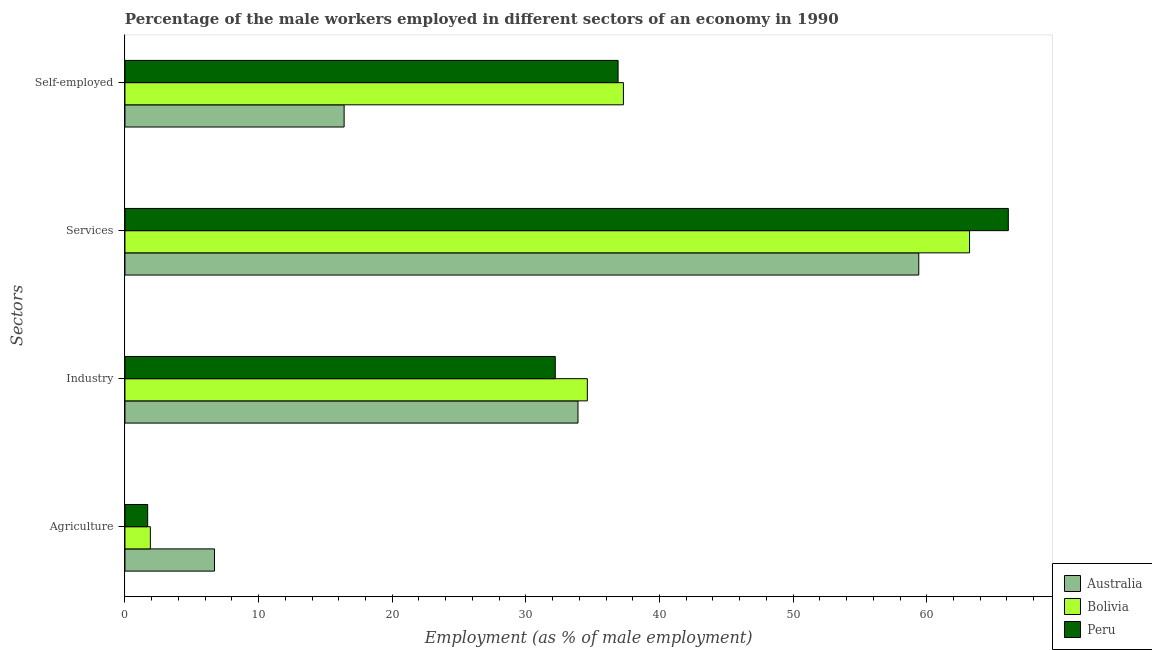How many different coloured bars are there?
Provide a succinct answer. 3. Are the number of bars on each tick of the Y-axis equal?
Your answer should be very brief. Yes. How many bars are there on the 1st tick from the bottom?
Your answer should be very brief. 3. What is the label of the 3rd group of bars from the top?
Keep it short and to the point. Industry. What is the percentage of male workers in agriculture in Bolivia?
Provide a short and direct response. 1.9. Across all countries, what is the maximum percentage of self employed male workers?
Your answer should be very brief. 37.3. Across all countries, what is the minimum percentage of self employed male workers?
Your answer should be very brief. 16.4. What is the total percentage of self employed male workers in the graph?
Your response must be concise. 90.6. What is the difference between the percentage of male workers in industry in Peru and that in Australia?
Your answer should be compact. -1.7. What is the difference between the percentage of male workers in services in Bolivia and the percentage of male workers in industry in Peru?
Offer a terse response. 31. What is the average percentage of male workers in industry per country?
Ensure brevity in your answer.  33.57. What is the difference between the percentage of self employed male workers and percentage of male workers in agriculture in Bolivia?
Offer a very short reply. 35.4. What is the ratio of the percentage of male workers in services in Peru to that in Australia?
Give a very brief answer. 1.11. Is the percentage of male workers in industry in Peru less than that in Bolivia?
Give a very brief answer. Yes. What is the difference between the highest and the second highest percentage of self employed male workers?
Your answer should be very brief. 0.4. What is the difference between the highest and the lowest percentage of male workers in industry?
Your answer should be compact. 2.4. In how many countries, is the percentage of male workers in services greater than the average percentage of male workers in services taken over all countries?
Provide a succinct answer. 2. Is it the case that in every country, the sum of the percentage of male workers in agriculture and percentage of self employed male workers is greater than the sum of percentage of male workers in services and percentage of male workers in industry?
Provide a succinct answer. No. Is it the case that in every country, the sum of the percentage of male workers in agriculture and percentage of male workers in industry is greater than the percentage of male workers in services?
Offer a very short reply. No. How many bars are there?
Provide a short and direct response. 12. Are all the bars in the graph horizontal?
Your answer should be very brief. Yes. How many countries are there in the graph?
Keep it short and to the point. 3. Are the values on the major ticks of X-axis written in scientific E-notation?
Ensure brevity in your answer.  No. Does the graph contain grids?
Provide a succinct answer. No. Where does the legend appear in the graph?
Ensure brevity in your answer.  Bottom right. How are the legend labels stacked?
Your answer should be very brief. Vertical. What is the title of the graph?
Make the answer very short. Percentage of the male workers employed in different sectors of an economy in 1990. Does "Syrian Arab Republic" appear as one of the legend labels in the graph?
Your answer should be very brief. No. What is the label or title of the X-axis?
Offer a very short reply. Employment (as % of male employment). What is the label or title of the Y-axis?
Give a very brief answer. Sectors. What is the Employment (as % of male employment) of Australia in Agriculture?
Provide a succinct answer. 6.7. What is the Employment (as % of male employment) of Bolivia in Agriculture?
Provide a short and direct response. 1.9. What is the Employment (as % of male employment) in Peru in Agriculture?
Give a very brief answer. 1.7. What is the Employment (as % of male employment) in Australia in Industry?
Make the answer very short. 33.9. What is the Employment (as % of male employment) in Bolivia in Industry?
Give a very brief answer. 34.6. What is the Employment (as % of male employment) of Peru in Industry?
Ensure brevity in your answer.  32.2. What is the Employment (as % of male employment) in Australia in Services?
Offer a terse response. 59.4. What is the Employment (as % of male employment) in Bolivia in Services?
Provide a succinct answer. 63.2. What is the Employment (as % of male employment) of Peru in Services?
Keep it short and to the point. 66.1. What is the Employment (as % of male employment) in Australia in Self-employed?
Your answer should be very brief. 16.4. What is the Employment (as % of male employment) of Bolivia in Self-employed?
Give a very brief answer. 37.3. What is the Employment (as % of male employment) in Peru in Self-employed?
Give a very brief answer. 36.9. Across all Sectors, what is the maximum Employment (as % of male employment) of Australia?
Offer a terse response. 59.4. Across all Sectors, what is the maximum Employment (as % of male employment) of Bolivia?
Offer a terse response. 63.2. Across all Sectors, what is the maximum Employment (as % of male employment) of Peru?
Provide a short and direct response. 66.1. Across all Sectors, what is the minimum Employment (as % of male employment) in Australia?
Provide a short and direct response. 6.7. Across all Sectors, what is the minimum Employment (as % of male employment) of Bolivia?
Your response must be concise. 1.9. Across all Sectors, what is the minimum Employment (as % of male employment) of Peru?
Give a very brief answer. 1.7. What is the total Employment (as % of male employment) of Australia in the graph?
Provide a succinct answer. 116.4. What is the total Employment (as % of male employment) of Bolivia in the graph?
Give a very brief answer. 137. What is the total Employment (as % of male employment) in Peru in the graph?
Ensure brevity in your answer.  136.9. What is the difference between the Employment (as % of male employment) in Australia in Agriculture and that in Industry?
Keep it short and to the point. -27.2. What is the difference between the Employment (as % of male employment) of Bolivia in Agriculture and that in Industry?
Your answer should be very brief. -32.7. What is the difference between the Employment (as % of male employment) of Peru in Agriculture and that in Industry?
Offer a very short reply. -30.5. What is the difference between the Employment (as % of male employment) of Australia in Agriculture and that in Services?
Offer a terse response. -52.7. What is the difference between the Employment (as % of male employment) in Bolivia in Agriculture and that in Services?
Provide a short and direct response. -61.3. What is the difference between the Employment (as % of male employment) in Peru in Agriculture and that in Services?
Provide a short and direct response. -64.4. What is the difference between the Employment (as % of male employment) in Australia in Agriculture and that in Self-employed?
Your answer should be very brief. -9.7. What is the difference between the Employment (as % of male employment) in Bolivia in Agriculture and that in Self-employed?
Offer a very short reply. -35.4. What is the difference between the Employment (as % of male employment) in Peru in Agriculture and that in Self-employed?
Your answer should be compact. -35.2. What is the difference between the Employment (as % of male employment) of Australia in Industry and that in Services?
Provide a short and direct response. -25.5. What is the difference between the Employment (as % of male employment) in Bolivia in Industry and that in Services?
Keep it short and to the point. -28.6. What is the difference between the Employment (as % of male employment) of Peru in Industry and that in Services?
Keep it short and to the point. -33.9. What is the difference between the Employment (as % of male employment) in Australia in Industry and that in Self-employed?
Ensure brevity in your answer.  17.5. What is the difference between the Employment (as % of male employment) in Bolivia in Industry and that in Self-employed?
Offer a terse response. -2.7. What is the difference between the Employment (as % of male employment) of Peru in Industry and that in Self-employed?
Offer a terse response. -4.7. What is the difference between the Employment (as % of male employment) of Bolivia in Services and that in Self-employed?
Offer a terse response. 25.9. What is the difference between the Employment (as % of male employment) of Peru in Services and that in Self-employed?
Your answer should be compact. 29.2. What is the difference between the Employment (as % of male employment) in Australia in Agriculture and the Employment (as % of male employment) in Bolivia in Industry?
Provide a short and direct response. -27.9. What is the difference between the Employment (as % of male employment) in Australia in Agriculture and the Employment (as % of male employment) in Peru in Industry?
Provide a short and direct response. -25.5. What is the difference between the Employment (as % of male employment) of Bolivia in Agriculture and the Employment (as % of male employment) of Peru in Industry?
Give a very brief answer. -30.3. What is the difference between the Employment (as % of male employment) in Australia in Agriculture and the Employment (as % of male employment) in Bolivia in Services?
Your answer should be compact. -56.5. What is the difference between the Employment (as % of male employment) of Australia in Agriculture and the Employment (as % of male employment) of Peru in Services?
Provide a short and direct response. -59.4. What is the difference between the Employment (as % of male employment) of Bolivia in Agriculture and the Employment (as % of male employment) of Peru in Services?
Provide a succinct answer. -64.2. What is the difference between the Employment (as % of male employment) of Australia in Agriculture and the Employment (as % of male employment) of Bolivia in Self-employed?
Your answer should be compact. -30.6. What is the difference between the Employment (as % of male employment) in Australia in Agriculture and the Employment (as % of male employment) in Peru in Self-employed?
Provide a succinct answer. -30.2. What is the difference between the Employment (as % of male employment) in Bolivia in Agriculture and the Employment (as % of male employment) in Peru in Self-employed?
Keep it short and to the point. -35. What is the difference between the Employment (as % of male employment) in Australia in Industry and the Employment (as % of male employment) in Bolivia in Services?
Your answer should be compact. -29.3. What is the difference between the Employment (as % of male employment) of Australia in Industry and the Employment (as % of male employment) of Peru in Services?
Provide a short and direct response. -32.2. What is the difference between the Employment (as % of male employment) in Bolivia in Industry and the Employment (as % of male employment) in Peru in Services?
Ensure brevity in your answer.  -31.5. What is the difference between the Employment (as % of male employment) of Australia in Industry and the Employment (as % of male employment) of Bolivia in Self-employed?
Your answer should be very brief. -3.4. What is the difference between the Employment (as % of male employment) in Australia in Industry and the Employment (as % of male employment) in Peru in Self-employed?
Your response must be concise. -3. What is the difference between the Employment (as % of male employment) in Bolivia in Industry and the Employment (as % of male employment) in Peru in Self-employed?
Offer a terse response. -2.3. What is the difference between the Employment (as % of male employment) in Australia in Services and the Employment (as % of male employment) in Bolivia in Self-employed?
Offer a very short reply. 22.1. What is the difference between the Employment (as % of male employment) of Bolivia in Services and the Employment (as % of male employment) of Peru in Self-employed?
Make the answer very short. 26.3. What is the average Employment (as % of male employment) in Australia per Sectors?
Keep it short and to the point. 29.1. What is the average Employment (as % of male employment) in Bolivia per Sectors?
Make the answer very short. 34.25. What is the average Employment (as % of male employment) of Peru per Sectors?
Keep it short and to the point. 34.23. What is the difference between the Employment (as % of male employment) of Bolivia and Employment (as % of male employment) of Peru in Agriculture?
Give a very brief answer. 0.2. What is the difference between the Employment (as % of male employment) of Australia and Employment (as % of male employment) of Bolivia in Self-employed?
Offer a very short reply. -20.9. What is the difference between the Employment (as % of male employment) of Australia and Employment (as % of male employment) of Peru in Self-employed?
Give a very brief answer. -20.5. What is the ratio of the Employment (as % of male employment) in Australia in Agriculture to that in Industry?
Make the answer very short. 0.2. What is the ratio of the Employment (as % of male employment) of Bolivia in Agriculture to that in Industry?
Offer a very short reply. 0.05. What is the ratio of the Employment (as % of male employment) of Peru in Agriculture to that in Industry?
Offer a very short reply. 0.05. What is the ratio of the Employment (as % of male employment) of Australia in Agriculture to that in Services?
Provide a short and direct response. 0.11. What is the ratio of the Employment (as % of male employment) in Bolivia in Agriculture to that in Services?
Provide a succinct answer. 0.03. What is the ratio of the Employment (as % of male employment) in Peru in Agriculture to that in Services?
Ensure brevity in your answer.  0.03. What is the ratio of the Employment (as % of male employment) of Australia in Agriculture to that in Self-employed?
Give a very brief answer. 0.41. What is the ratio of the Employment (as % of male employment) in Bolivia in Agriculture to that in Self-employed?
Provide a short and direct response. 0.05. What is the ratio of the Employment (as % of male employment) of Peru in Agriculture to that in Self-employed?
Your answer should be very brief. 0.05. What is the ratio of the Employment (as % of male employment) in Australia in Industry to that in Services?
Keep it short and to the point. 0.57. What is the ratio of the Employment (as % of male employment) of Bolivia in Industry to that in Services?
Ensure brevity in your answer.  0.55. What is the ratio of the Employment (as % of male employment) of Peru in Industry to that in Services?
Ensure brevity in your answer.  0.49. What is the ratio of the Employment (as % of male employment) in Australia in Industry to that in Self-employed?
Keep it short and to the point. 2.07. What is the ratio of the Employment (as % of male employment) in Bolivia in Industry to that in Self-employed?
Ensure brevity in your answer.  0.93. What is the ratio of the Employment (as % of male employment) of Peru in Industry to that in Self-employed?
Offer a very short reply. 0.87. What is the ratio of the Employment (as % of male employment) in Australia in Services to that in Self-employed?
Give a very brief answer. 3.62. What is the ratio of the Employment (as % of male employment) in Bolivia in Services to that in Self-employed?
Ensure brevity in your answer.  1.69. What is the ratio of the Employment (as % of male employment) of Peru in Services to that in Self-employed?
Your answer should be compact. 1.79. What is the difference between the highest and the second highest Employment (as % of male employment) of Australia?
Your answer should be compact. 25.5. What is the difference between the highest and the second highest Employment (as % of male employment) in Bolivia?
Give a very brief answer. 25.9. What is the difference between the highest and the second highest Employment (as % of male employment) of Peru?
Provide a short and direct response. 29.2. What is the difference between the highest and the lowest Employment (as % of male employment) in Australia?
Make the answer very short. 52.7. What is the difference between the highest and the lowest Employment (as % of male employment) in Bolivia?
Keep it short and to the point. 61.3. What is the difference between the highest and the lowest Employment (as % of male employment) in Peru?
Provide a short and direct response. 64.4. 